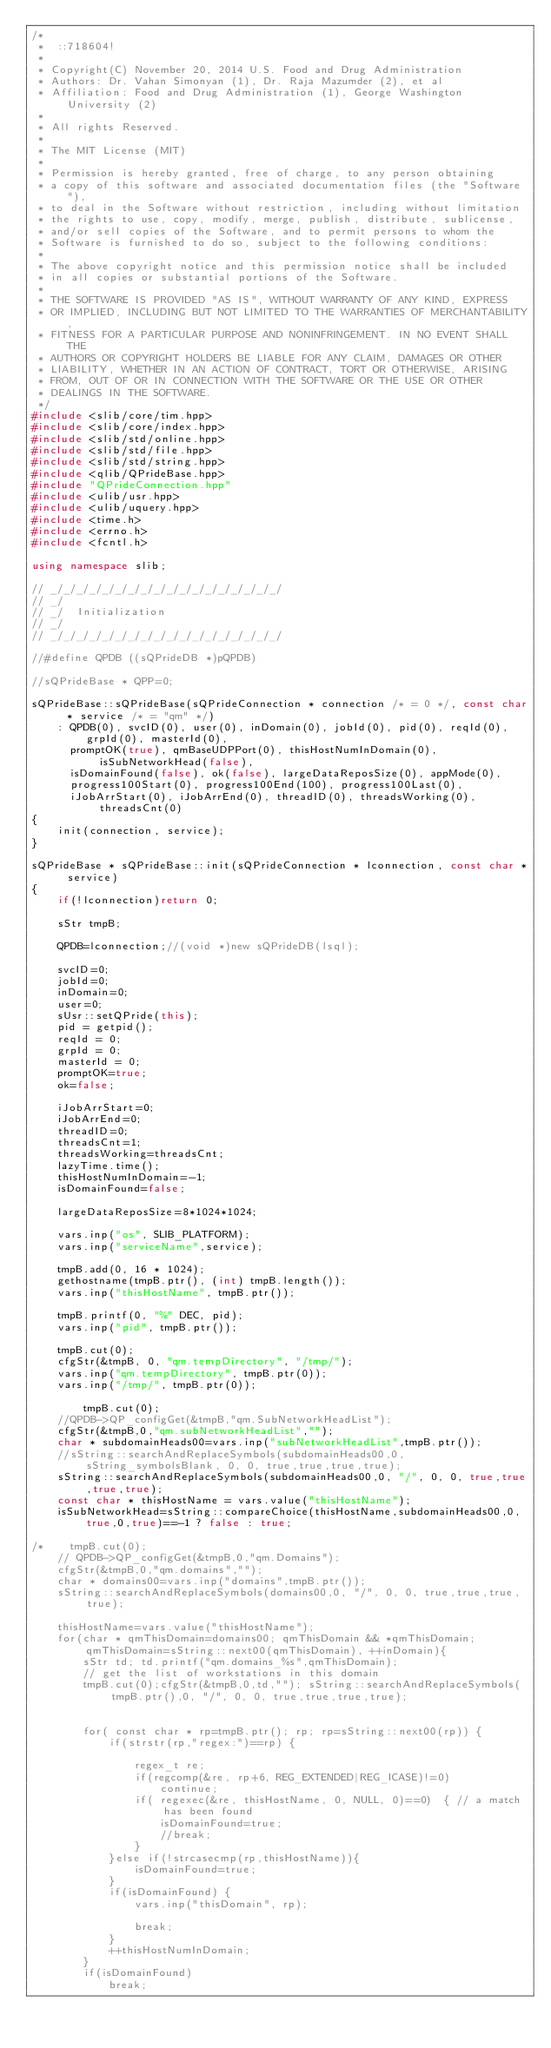<code> <loc_0><loc_0><loc_500><loc_500><_C++_>/*
 *  ::718604!
 * 
 * Copyright(C) November 20, 2014 U.S. Food and Drug Administration
 * Authors: Dr. Vahan Simonyan (1), Dr. Raja Mazumder (2), et al
 * Affiliation: Food and Drug Administration (1), George Washington University (2)
 * 
 * All rights Reserved.
 * 
 * The MIT License (MIT)
 * 
 * Permission is hereby granted, free of charge, to any person obtaining
 * a copy of this software and associated documentation files (the "Software"),
 * to deal in the Software without restriction, including without limitation
 * the rights to use, copy, modify, merge, publish, distribute, sublicense,
 * and/or sell copies of the Software, and to permit persons to whom the
 * Software is furnished to do so, subject to the following conditions:
 * 
 * The above copyright notice and this permission notice shall be included
 * in all copies or substantial portions of the Software.
 * 
 * THE SOFTWARE IS PROVIDED "AS IS", WITHOUT WARRANTY OF ANY KIND, EXPRESS
 * OR IMPLIED, INCLUDING BUT NOT LIMITED TO THE WARRANTIES OF MERCHANTABILITY,
 * FITNESS FOR A PARTICULAR PURPOSE AND NONINFRINGEMENT. IN NO EVENT SHALL THE
 * AUTHORS OR COPYRIGHT HOLDERS BE LIABLE FOR ANY CLAIM, DAMAGES OR OTHER
 * LIABILITY, WHETHER IN AN ACTION OF CONTRACT, TORT OR OTHERWISE, ARISING
 * FROM, OUT OF OR IN CONNECTION WITH THE SOFTWARE OR THE USE OR OTHER
 * DEALINGS IN THE SOFTWARE.
 */
#include <slib/core/tim.hpp>
#include <slib/core/index.hpp>
#include <slib/std/online.hpp>
#include <slib/std/file.hpp>
#include <slib/std/string.hpp>
#include <qlib/QPrideBase.hpp>
#include "QPrideConnection.hpp"
#include <ulib/usr.hpp>
#include <ulib/uquery.hpp>
#include <time.h>
#include <errno.h>
#include <fcntl.h>

using namespace slib;

// _/_/_/_/_/_/_/_/_/_/_/_/_/_/_/_/_/_/
// _/
// _/  Initialization
// _/
// _/_/_/_/_/_/_/_/_/_/_/_/_/_/_/_/_/_/

//#define QPDB ((sQPrideDB *)pQPDB)

//sQPrideBase * QPP=0;

sQPrideBase::sQPrideBase(sQPrideConnection * connection /* = 0 */, const char * service /* = "qm" */)
    : QPDB(0), svcID(0), user(0), inDomain(0), jobId(0), pid(0), reqId(0), grpId(0), masterId(0),
      promptOK(true), qmBaseUDPPort(0), thisHostNumInDomain(0), isSubNetworkHead(false),
      isDomainFound(false), ok(false), largeDataReposSize(0), appMode(0),
      progress100Start(0), progress100End(100), progress100Last(0),
      iJobArrStart(0), iJobArrEnd(0), threadID(0), threadsWorking(0), threadsCnt(0)
{
    init(connection, service);
}

sQPrideBase * sQPrideBase::init(sQPrideConnection * lconnection, const char * service)
{
    if(!lconnection)return 0;

    sStr tmpB;

    QPDB=lconnection;//(void *)new sQPrideDB(lsql);

    svcID=0;
    jobId=0;
    inDomain=0;
    user=0;
    sUsr::setQPride(this);
    pid = getpid();
    reqId = 0;
    grpId = 0;
    masterId = 0;
    promptOK=true;
    ok=false;

    iJobArrStart=0;
    iJobArrEnd=0;
    threadID=0;
    threadsCnt=1;
    threadsWorking=threadsCnt;
    lazyTime.time();
    thisHostNumInDomain=-1;
    isDomainFound=false;

    largeDataReposSize=8*1024*1024;

    vars.inp("os", SLIB_PLATFORM);
    vars.inp("serviceName",service);

    tmpB.add(0, 16 * 1024);
    gethostname(tmpB.ptr(), (int) tmpB.length());
    vars.inp("thisHostName", tmpB.ptr());

    tmpB.printf(0, "%" DEC, pid);
    vars.inp("pid", tmpB.ptr());

    tmpB.cut(0);
    cfgStr(&tmpB, 0, "qm.tempDirectory", "/tmp/");
    vars.inp("qm.tempDirectory", tmpB.ptr(0));
    vars.inp("/tmp/", tmpB.ptr(0));

        tmpB.cut(0);
    //QPDB->QP_configGet(&tmpB,"qm.SubNetworkHeadList");
    cfgStr(&tmpB,0,"qm.subNetworkHeadList","");
    char * subdomainHeads00=vars.inp("subNetworkHeadList",tmpB.ptr());
    //sString::searchAndReplaceSymbols(subdomainHeads00,0, sString_symbolsBlank, 0, 0, true,true,true,true);
    sString::searchAndReplaceSymbols(subdomainHeads00,0, "/", 0, 0, true,true,true,true);
    const char * thisHostName = vars.value("thisHostName");
    isSubNetworkHead=sString::compareChoice(thisHostName,subdomainHeads00,0,true,0,true)==-1 ? false : true;

/*    tmpB.cut(0);
    // QPDB->QP_configGet(&tmpB,0,"qm.Domains");
    cfgStr(&tmpB,0,"qm.domains","");
    char * domains00=vars.inp("domains",tmpB.ptr());
    sString::searchAndReplaceSymbols(domains00,0, "/", 0, 0, true,true,true,true);

    thisHostName=vars.value("thisHostName");
    for(char * qmThisDomain=domains00; qmThisDomain && *qmThisDomain; qmThisDomain=sString::next00(qmThisDomain), ++inDomain){
        sStr td; td.printf("qm.domains_%s",qmThisDomain);
        // get the list of workstations in this domain
        tmpB.cut(0);cfgStr(&tmpB,0,td,""); sString::searchAndReplaceSymbols(tmpB.ptr(),0, "/", 0, 0, true,true,true,true);


        for( const char * rp=tmpB.ptr(); rp; rp=sString::next00(rp)) {
            if(strstr(rp,"regex:")==rp) {

                regex_t re;
                if(regcomp(&re, rp+6, REG_EXTENDED|REG_ICASE)!=0)
                    continue;
                if( regexec(&re, thisHostName, 0, NULL, 0)==0)  { // a match has been found
                    isDomainFound=true;
                    //break;
                }
            }else if(!strcasecmp(rp,thisHostName)){
                isDomainFound=true;
            }
            if(isDomainFound) {
                vars.inp("thisDomain", rp);

                break;
            }
            ++thisHostNumInDomain;
        }
        if(isDomainFound)
            break;
</code> 